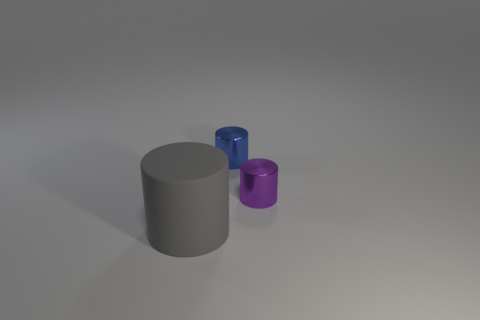Does the big rubber thing have the same color as the small thing that is behind the small purple cylinder?
Provide a succinct answer. No. The matte thing is what color?
Offer a terse response. Gray. What shape is the metallic object to the left of the small shiny cylinder that is in front of the tiny object that is on the left side of the purple shiny thing?
Give a very brief answer. Cylinder. Are there more small blue cylinders left of the large gray matte cylinder than large gray cylinders that are right of the purple object?
Your answer should be very brief. No. There is a tiny blue shiny cylinder; are there any small metal cylinders to the right of it?
Provide a succinct answer. Yes. What material is the object that is both behind the matte cylinder and in front of the blue cylinder?
Offer a terse response. Metal. What color is the other tiny shiny thing that is the same shape as the tiny blue thing?
Make the answer very short. Purple. Are there any blue things that are on the right side of the small shiny cylinder that is behind the tiny purple metal object?
Provide a short and direct response. No. The purple shiny cylinder has what size?
Offer a very short reply. Small. There is a thing that is both on the left side of the purple cylinder and in front of the blue thing; what shape is it?
Provide a short and direct response. Cylinder. 